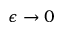<formula> <loc_0><loc_0><loc_500><loc_500>\epsilon \to 0</formula> 